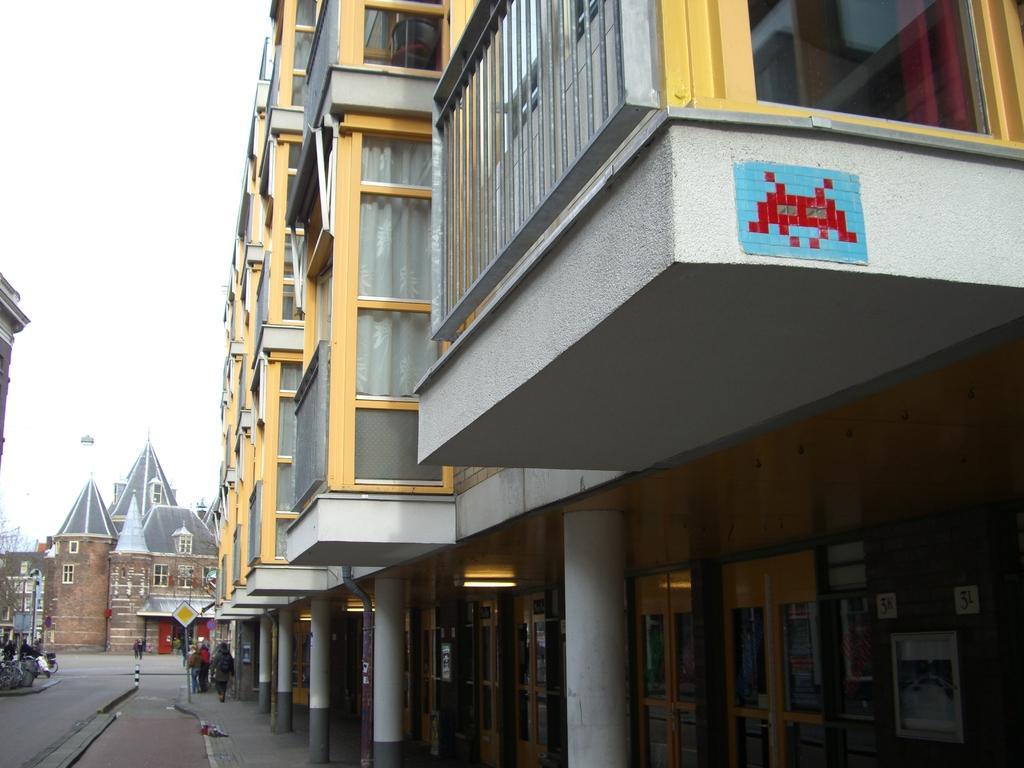In one or two sentences, can you explain what this image depicts? In this picture we see front edges of many buildings with supporting pillars. On the left side, we see people walking on the street. 